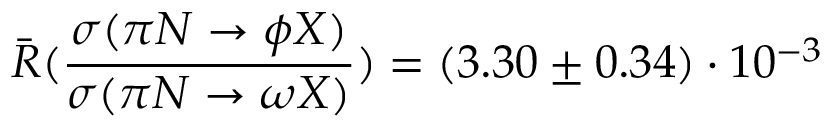Convert formula to latex. <formula><loc_0><loc_0><loc_500><loc_500>\bar { R } ( \frac { \sigma ( \pi N \to \phi X ) } { \sigma ( \pi N \to \omega X ) } ) = ( 3 . 3 0 \pm 0 . 3 4 ) \cdot 1 0 ^ { - 3 }</formula> 